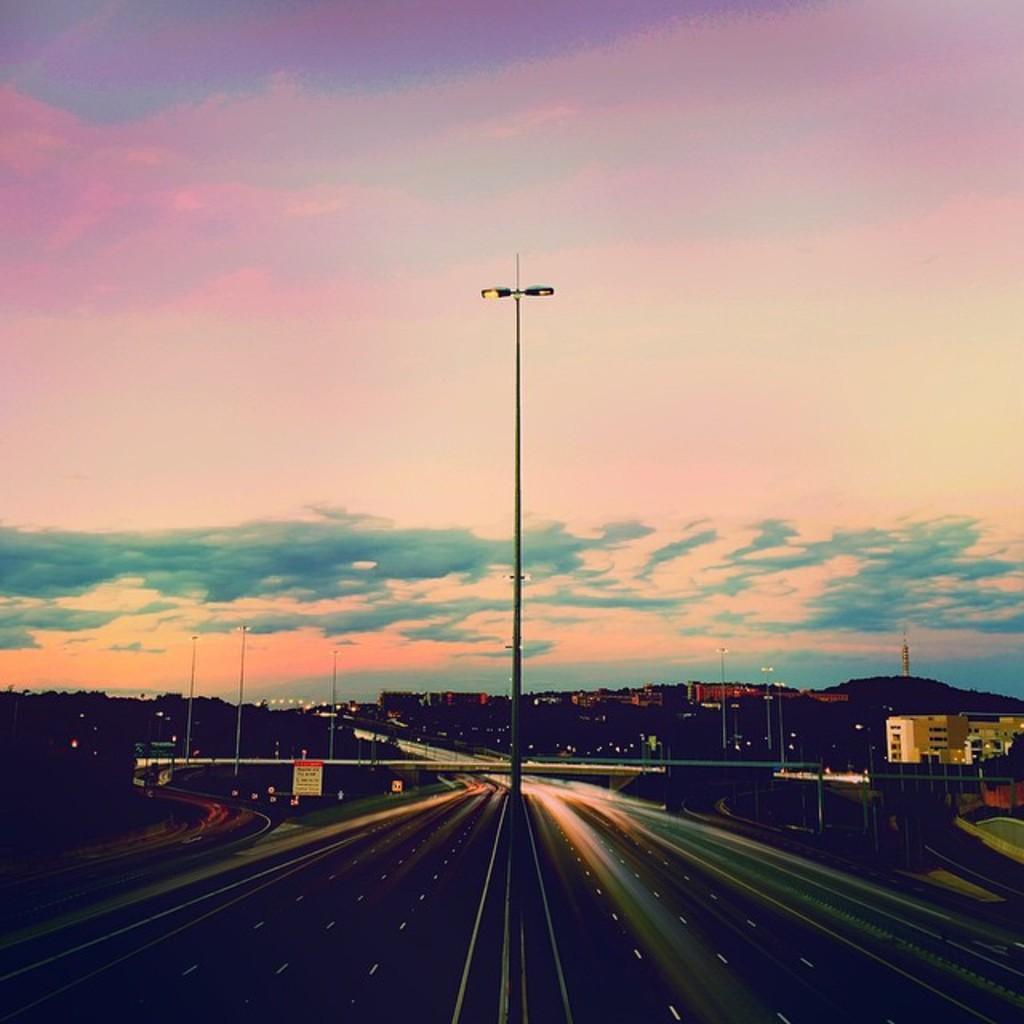How would you summarize this image in a sentence or two? In this picture we can see the view of the road in the front bottom side. Behind there is a street pole and some buildings. On the top we can see the sky and clouds. 